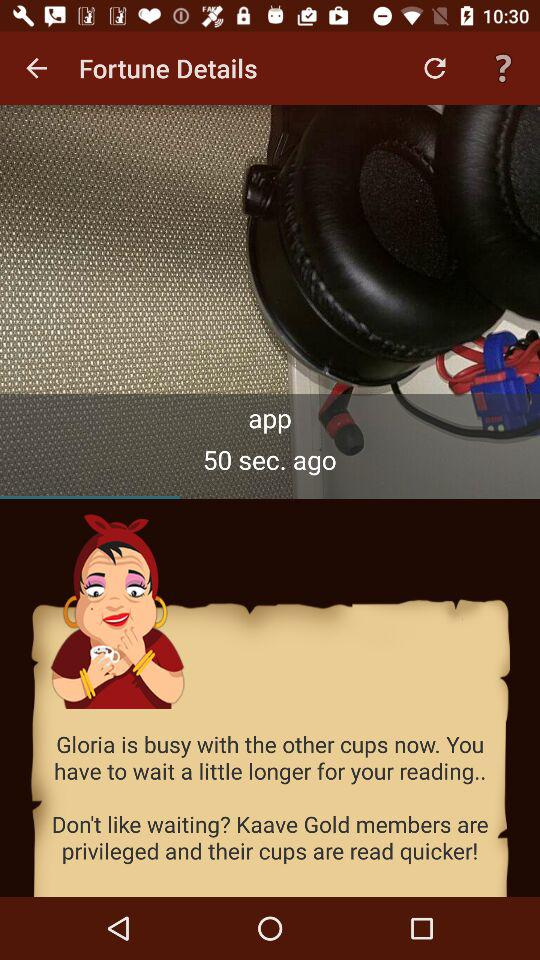How many seconds ago was the last fortune?
Answer the question using a single word or phrase. 50 